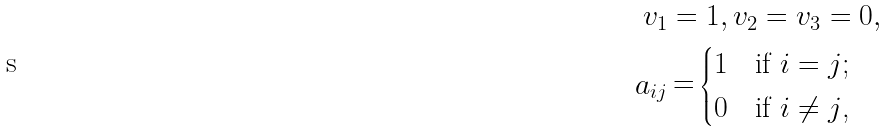Convert formula to latex. <formula><loc_0><loc_0><loc_500><loc_500>v _ { 1 } & = 1 , v _ { 2 } = v _ { 3 } = 0 , \\ a _ { i j } & \mathop = \begin{cases} 1 & \text {if $i=j$;} \\ 0 & \text {if $i\ne j$,} \end{cases}</formula> 